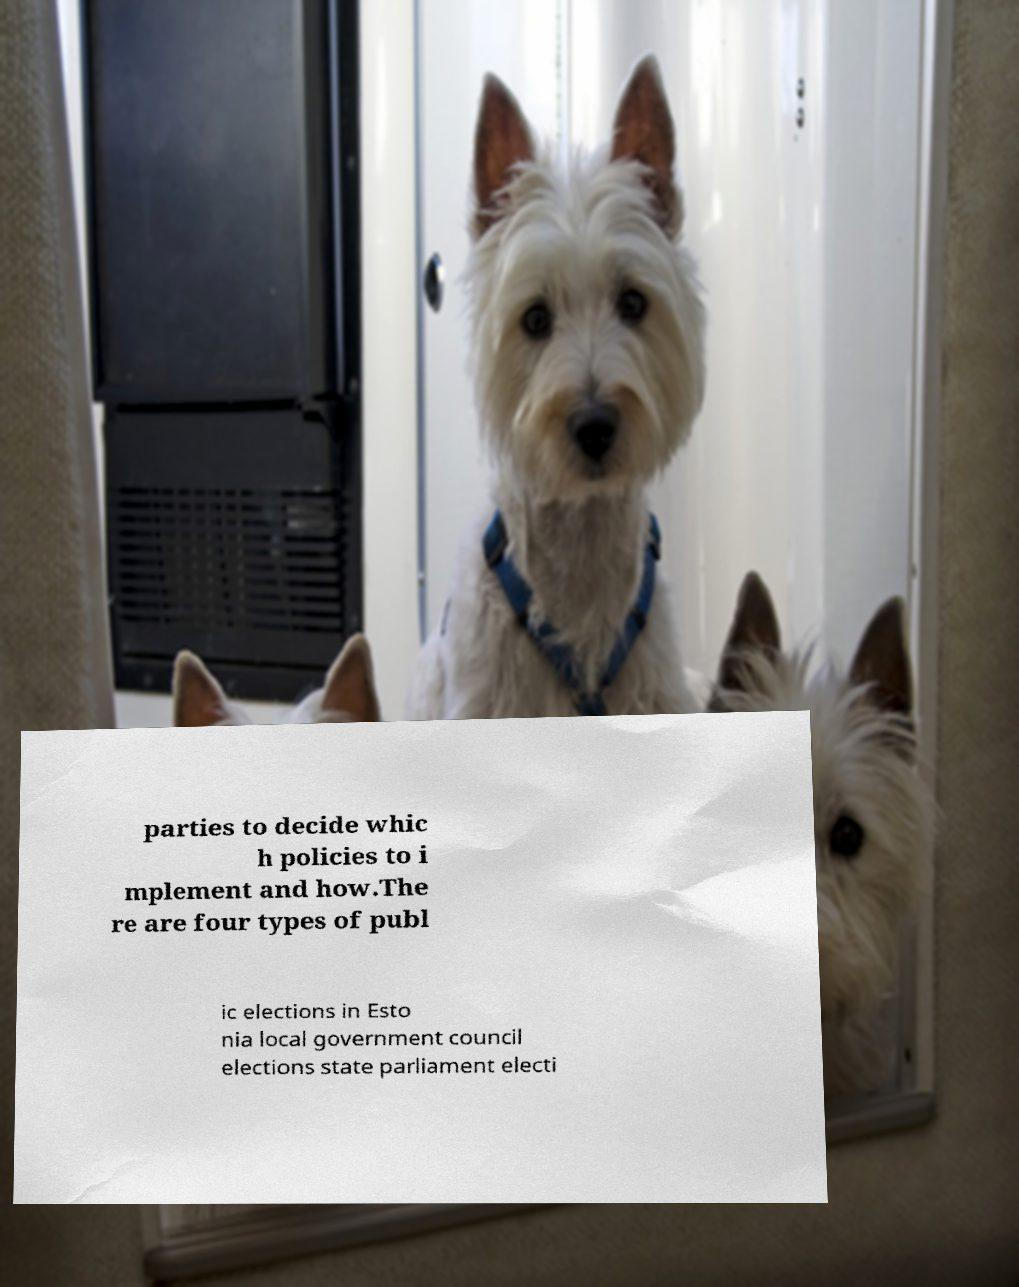Can you accurately transcribe the text from the provided image for me? parties to decide whic h policies to i mplement and how.The re are four types of publ ic elections in Esto nia local government council elections state parliament electi 